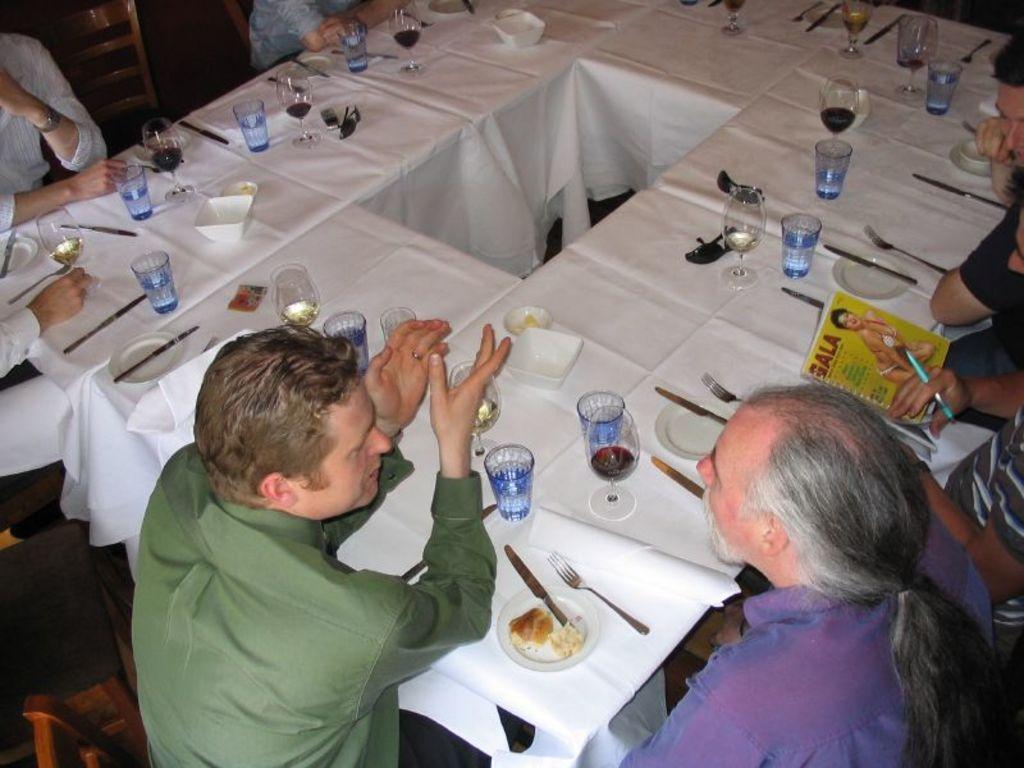Could you give a brief overview of what you see in this image? In this picture we can see people sitting on chair and in front of them there is table and on table we can see cloth, glasses, plate, knife, fork, book, google, mobile, paper, bowl, some food. 